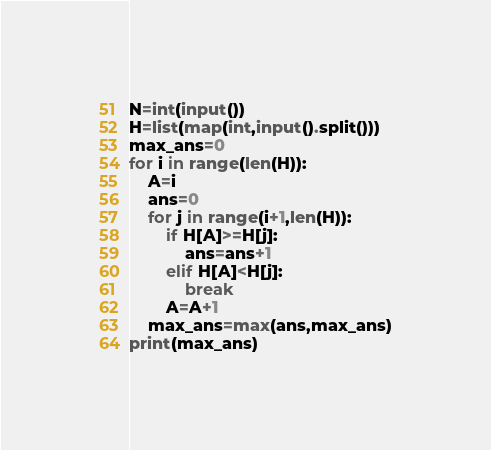Convert code to text. <code><loc_0><loc_0><loc_500><loc_500><_Python_>N=int(input())
H=list(map(int,input().split()))
max_ans=0
for i in range(len(H)):
    A=i
    ans=0
    for j in range(i+1,len(H)):
        if H[A]>=H[j]:
            ans=ans+1
        elif H[A]<H[j]:
            break
        A=A+1
    max_ans=max(ans,max_ans)
print(max_ans)</code> 